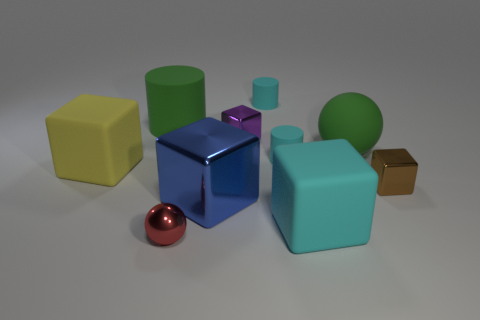Describe the color palette used in this image. The image exhibits a harmonious color palette with primary colors like blue and red, secondary colors such as green, and tertiary tones including cyan and yellow. All colors have a matte or slightly shiny finish, contributing to a visually appealing composition. 